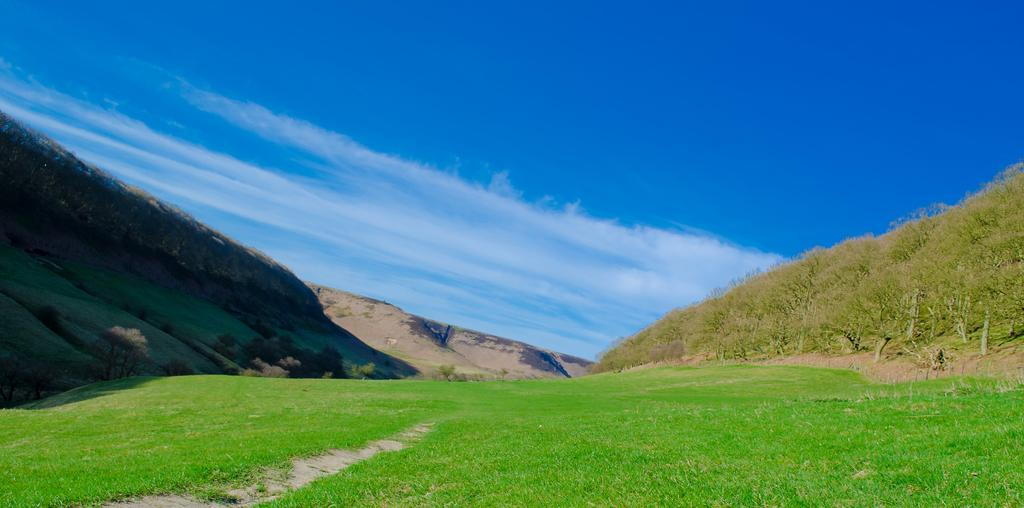What type of landscape is depicted in the image? There is a grassland in the image. What can be seen on the right side of the image? There is a hill with trees on the right side of the image. What is on the left side of the image? There is another hill on the left side of the image. What is visible in the sky in the image? The sky is visible in the image, and there are clouds in the sky. How many lead pipes can be seen in the image? There are no lead pipes present in the image. What event is taking place in the image related to a birth? There is no event related to a birth depicted in the image. 